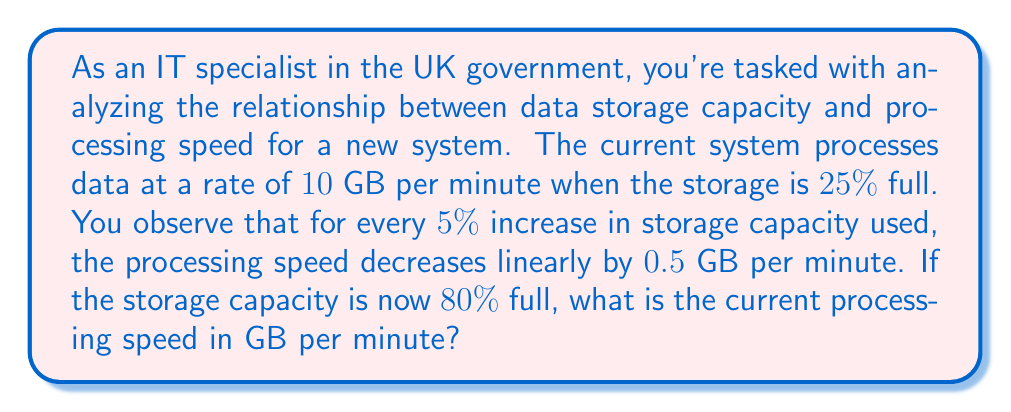Could you help me with this problem? Let's approach this step-by-step:

1) First, we need to calculate the change in storage capacity:
   $80\% - 25\% = 55\%$ increase

2) We know that for every $5\%$ increase, the speed decreases by $0.5$ GB/min.
   So, we need to find out how many $5\%$ increments are in $55\%$:
   $55\% \div 5\% = 11$

3) Now, we can calculate the total decrease in processing speed:
   $11 \times 0.5$ GB/min $= 5.5$ GB/min

4) The original processing speed was $10$ GB/min, so we subtract the decrease:
   $10$ GB/min $- 5.5$ GB/min $= 4.5$ GB/min

Therefore, the current processing speed when the storage is $80\%$ full is $4.5$ GB/min.
Answer: $4.5$ GB/min 